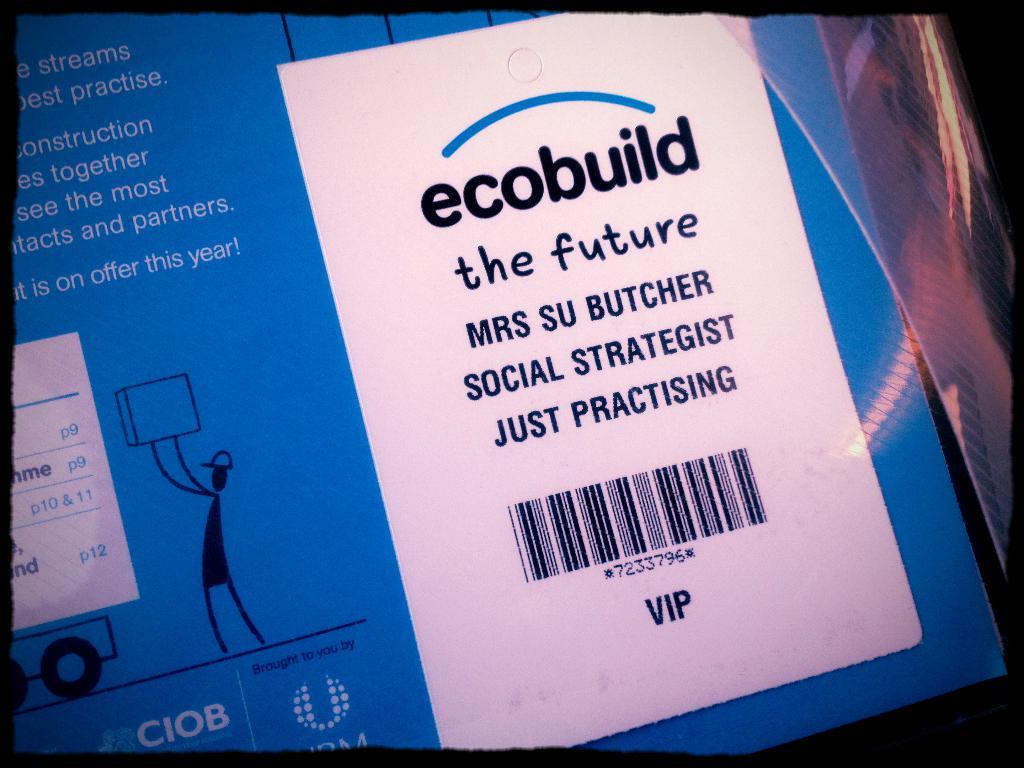<image>
Create a compact narrative representing the image presented. A box that has the word ecobuild on the top of the page. 